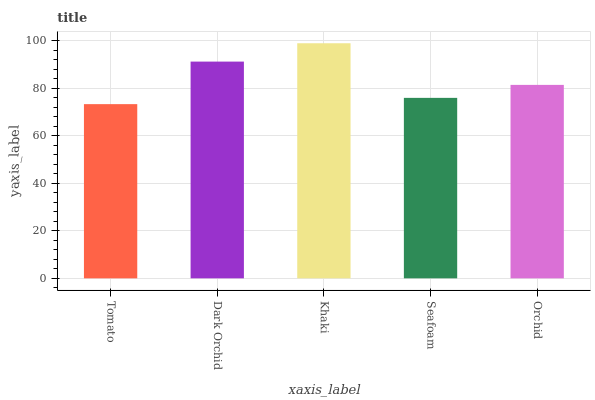Is Dark Orchid the minimum?
Answer yes or no. No. Is Dark Orchid the maximum?
Answer yes or no. No. Is Dark Orchid greater than Tomato?
Answer yes or no. Yes. Is Tomato less than Dark Orchid?
Answer yes or no. Yes. Is Tomato greater than Dark Orchid?
Answer yes or no. No. Is Dark Orchid less than Tomato?
Answer yes or no. No. Is Orchid the high median?
Answer yes or no. Yes. Is Orchid the low median?
Answer yes or no. Yes. Is Seafoam the high median?
Answer yes or no. No. Is Tomato the low median?
Answer yes or no. No. 